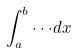Convert formula to latex. <formula><loc_0><loc_0><loc_500><loc_500>\int _ { a } ^ { b } \cdot \cdot \cdot d x</formula> 